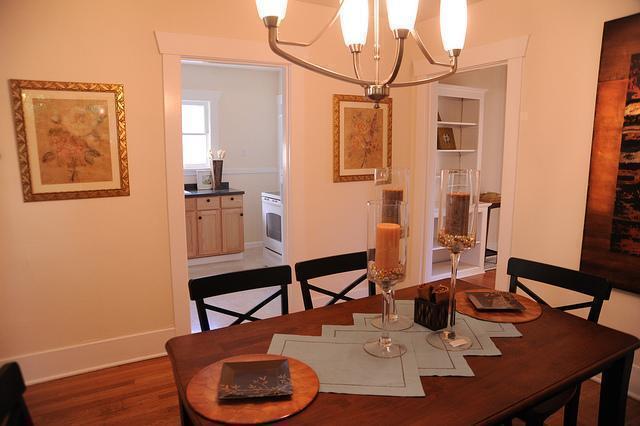What is inside the tall glasses?
Indicate the correct choice and explain in the format: 'Answer: answer
Rationale: rationale.'
Options: Candles, beer, wine, candy. Answer: candles.
Rationale: The glasses are holding the pillar variety of this type of home decor. 